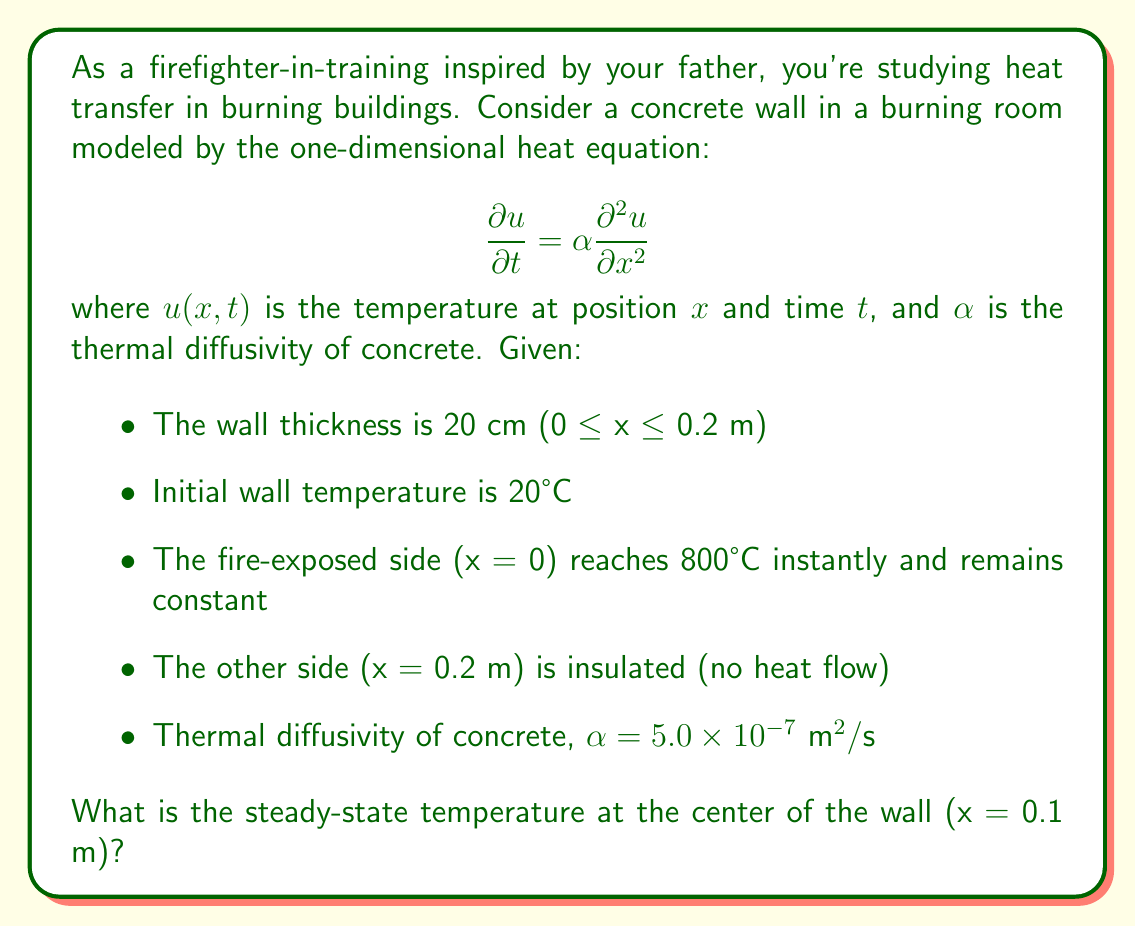Help me with this question. To solve this problem, we need to find the steady-state solution of the heat equation with the given boundary conditions. In steady-state, the temperature doesn't change with time, so $\frac{\partial u}{\partial t} = 0$.

1) The steady-state heat equation becomes:

   $$0 = \alpha \frac{d^2 u}{dx^2}$$

2) Integrating twice:

   $$u(x) = C_1x + C_2$$

3) Applying boundary conditions:
   - At x = 0, u(0) = 800°C, so C_2 = 800
   - At x = 0.2 m, $\frac{du}{dx} = 0$ (insulated), so C_1 = 0

4) Therefore, the steady-state temperature distribution is:

   $$u(x) = 800$$

5) This means the temperature is constant throughout the wall at steady-state.

6) At the center of the wall (x = 0.1 m), the temperature is also 800°C.

Note: In reality, it would take a very long time to reach this steady-state, and the concrete might deteriorate before reaching this temperature. This idealized model helps understand the concept of heat transfer in extreme conditions.
Answer: 800°C 